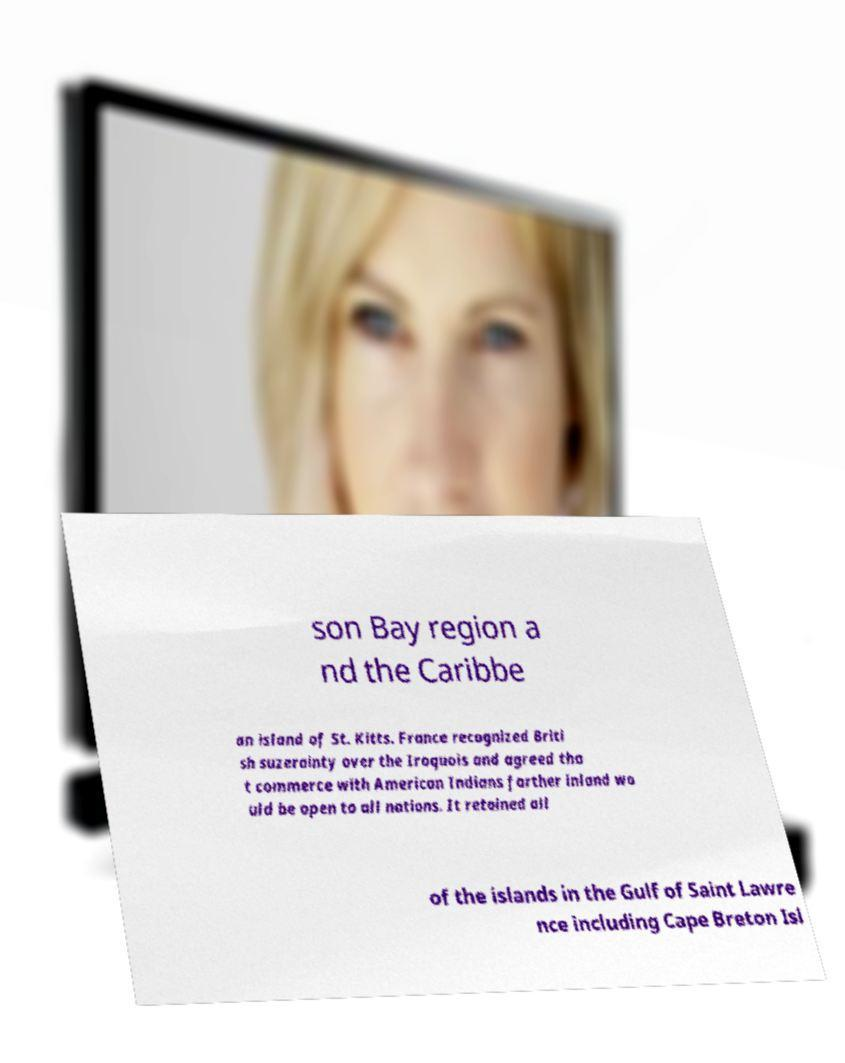There's text embedded in this image that I need extracted. Can you transcribe it verbatim? son Bay region a nd the Caribbe an island of St. Kitts. France recognized Briti sh suzerainty over the Iroquois and agreed tha t commerce with American Indians farther inland wo uld be open to all nations. It retained all of the islands in the Gulf of Saint Lawre nce including Cape Breton Isl 